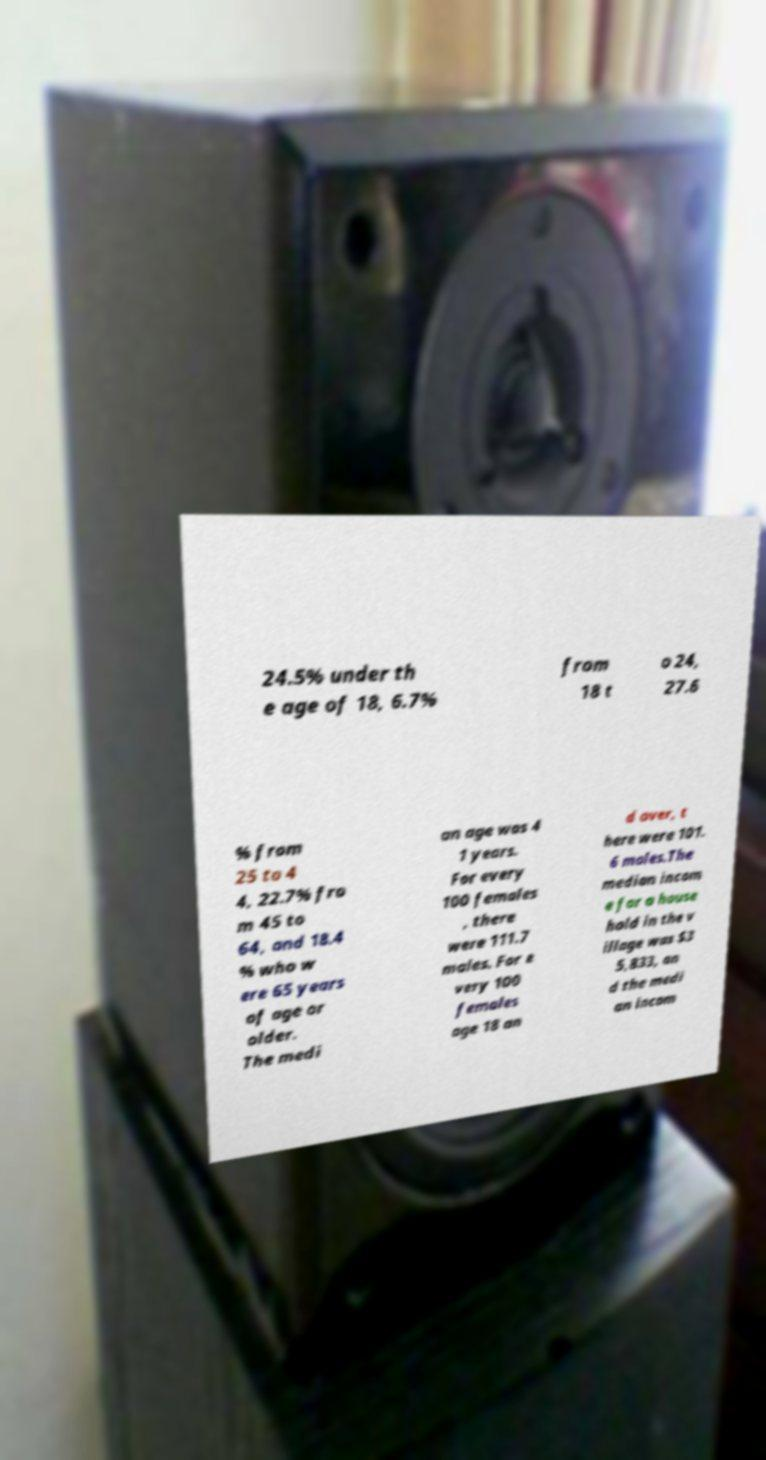Can you read and provide the text displayed in the image?This photo seems to have some interesting text. Can you extract and type it out for me? 24.5% under th e age of 18, 6.7% from 18 t o 24, 27.6 % from 25 to 4 4, 22.7% fro m 45 to 64, and 18.4 % who w ere 65 years of age or older. The medi an age was 4 1 years. For every 100 females , there were 111.7 males. For e very 100 females age 18 an d over, t here were 101. 6 males.The median incom e for a house hold in the v illage was $3 5,833, an d the medi an incom 